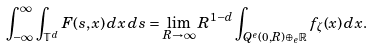Convert formula to latex. <formula><loc_0><loc_0><loc_500><loc_500>\int _ { - \infty } ^ { \infty } \int _ { \mathbb { T } ^ { d } } F ( s , x ) \, d x \, d s = \lim _ { R \to \infty } R ^ { 1 - d } \int _ { Q ^ { e } ( 0 , R ) \oplus _ { e } \mathbb { R } } f _ { \zeta } ( x ) \, d x .</formula> 